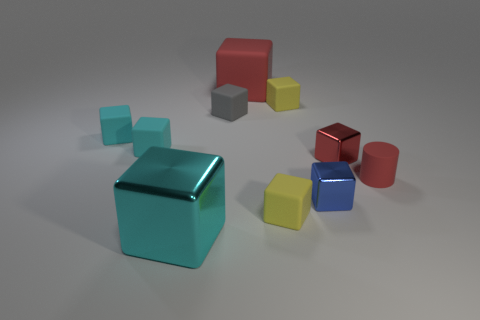Is the number of small yellow rubber things greater than the number of tiny matte blocks?
Your response must be concise. No. There is a tiny rubber cube that is in front of the small red block; does it have the same color as the big matte cube?
Provide a short and direct response. No. What number of objects are either metal objects that are in front of the blue metal object or tiny matte things left of the large cyan metal cube?
Your answer should be very brief. 3. What number of cubes are both in front of the small blue thing and behind the big cyan shiny block?
Provide a succinct answer. 1. Are the big red thing and the gray cube made of the same material?
Your answer should be very brief. Yes. What is the shape of the yellow object that is in front of the gray cube that is behind the tiny yellow rubber block that is in front of the small gray thing?
Your response must be concise. Cube. There is a tiny block that is both behind the red metallic thing and to the right of the big rubber block; what is its material?
Your answer should be compact. Rubber. What is the color of the big cube that is on the left side of the big cube behind the big object left of the tiny gray rubber cube?
Your answer should be very brief. Cyan. What number of blue objects are tiny matte cylinders or metallic cubes?
Provide a short and direct response. 1. What number of other objects are there of the same size as the cyan metallic block?
Keep it short and to the point. 1. 